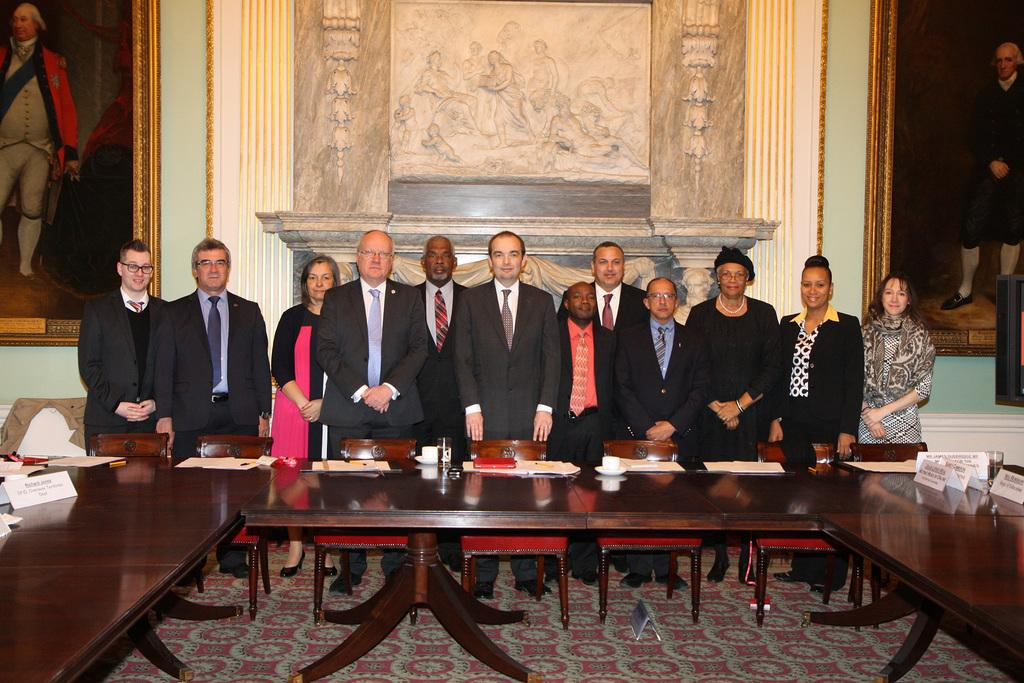What can be seen in the image involving people? There are people standing in the image. What furniture is present in the image? There are chairs in the image. What might be used for identification purposes in the image? Name boards are present in the image. What items are visible that might be used for drinking or eating? Cups and saucers are visible in the image. What is on the table in the image? There are objects on a table in the image. What can be seen on the wall in the background of the image? Frames are present on the wall in the background of the image. How many rabbits can be seen hopping on the people's toes in the image? There are no rabbits or toes visible in the image. What is the cause of the objects being crushed on the table in the image? There is no indication of any objects being crushed on the table in the image. 